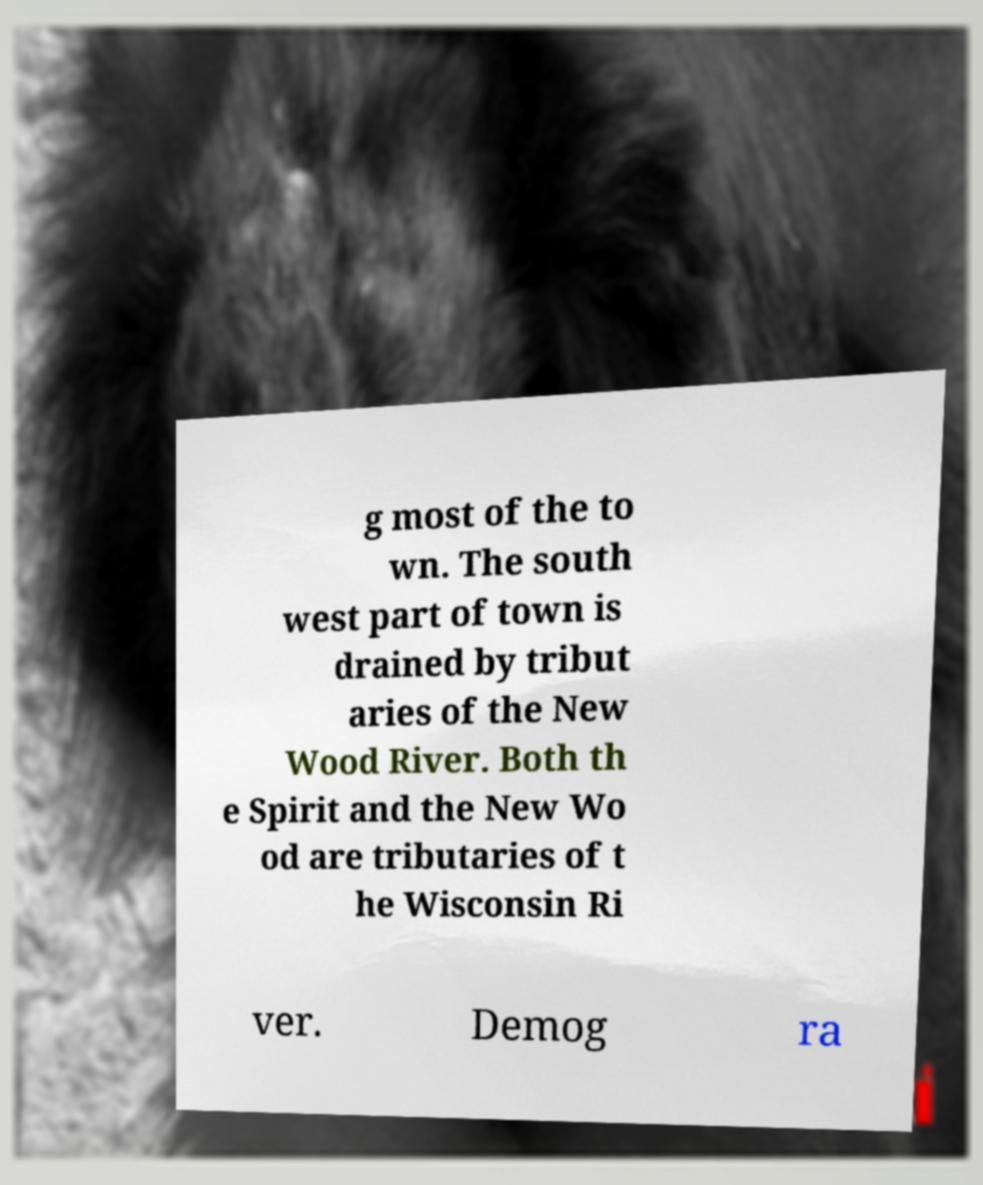Can you accurately transcribe the text from the provided image for me? g most of the to wn. The south west part of town is drained by tribut aries of the New Wood River. Both th e Spirit and the New Wo od are tributaries of t he Wisconsin Ri ver. Demog ra 